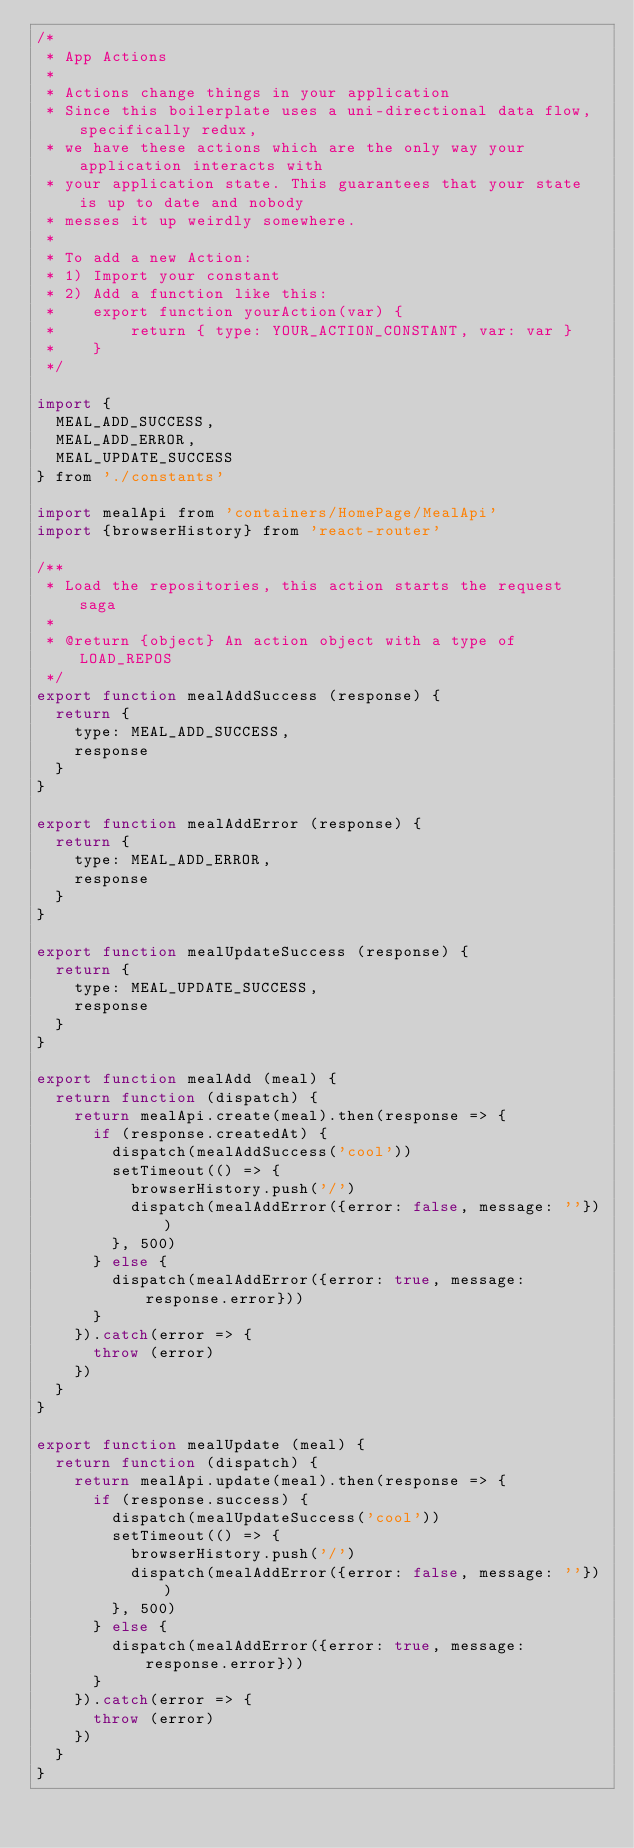<code> <loc_0><loc_0><loc_500><loc_500><_JavaScript_>/*
 * App Actions
 *
 * Actions change things in your application
 * Since this boilerplate uses a uni-directional data flow, specifically redux,
 * we have these actions which are the only way your application interacts with
 * your application state. This guarantees that your state is up to date and nobody
 * messes it up weirdly somewhere.
 *
 * To add a new Action:
 * 1) Import your constant
 * 2) Add a function like this:
 *    export function yourAction(var) {
 *        return { type: YOUR_ACTION_CONSTANT, var: var }
 *    }
 */

import {
  MEAL_ADD_SUCCESS,
  MEAL_ADD_ERROR,
  MEAL_UPDATE_SUCCESS
} from './constants'

import mealApi from 'containers/HomePage/MealApi'
import {browserHistory} from 'react-router'

/**
 * Load the repositories, this action starts the request saga
 *
 * @return {object} An action object with a type of LOAD_REPOS
 */
export function mealAddSuccess (response) {
  return {
    type: MEAL_ADD_SUCCESS,
    response
  }
}

export function mealAddError (response) {
  return {
    type: MEAL_ADD_ERROR,
    response
  }
}

export function mealUpdateSuccess (response) {
  return {
    type: MEAL_UPDATE_SUCCESS,
    response
  }
}

export function mealAdd (meal) {
  return function (dispatch) {
    return mealApi.create(meal).then(response => {
      if (response.createdAt) {
        dispatch(mealAddSuccess('cool'))
        setTimeout(() => {
          browserHistory.push('/')
          dispatch(mealAddError({error: false, message: ''}))
        }, 500)
      } else {
        dispatch(mealAddError({error: true, message: response.error}))
      }
    }).catch(error => {
      throw (error)
    })
  }
}

export function mealUpdate (meal) {
  return function (dispatch) {
    return mealApi.update(meal).then(response => {
      if (response.success) {
        dispatch(mealUpdateSuccess('cool'))
        setTimeout(() => {
          browserHistory.push('/')
          dispatch(mealAddError({error: false, message: ''}))
        }, 500)
      } else {
        dispatch(mealAddError({error: true, message: response.error}))
      }
    }).catch(error => {
      throw (error)
    })
  }
}
</code> 